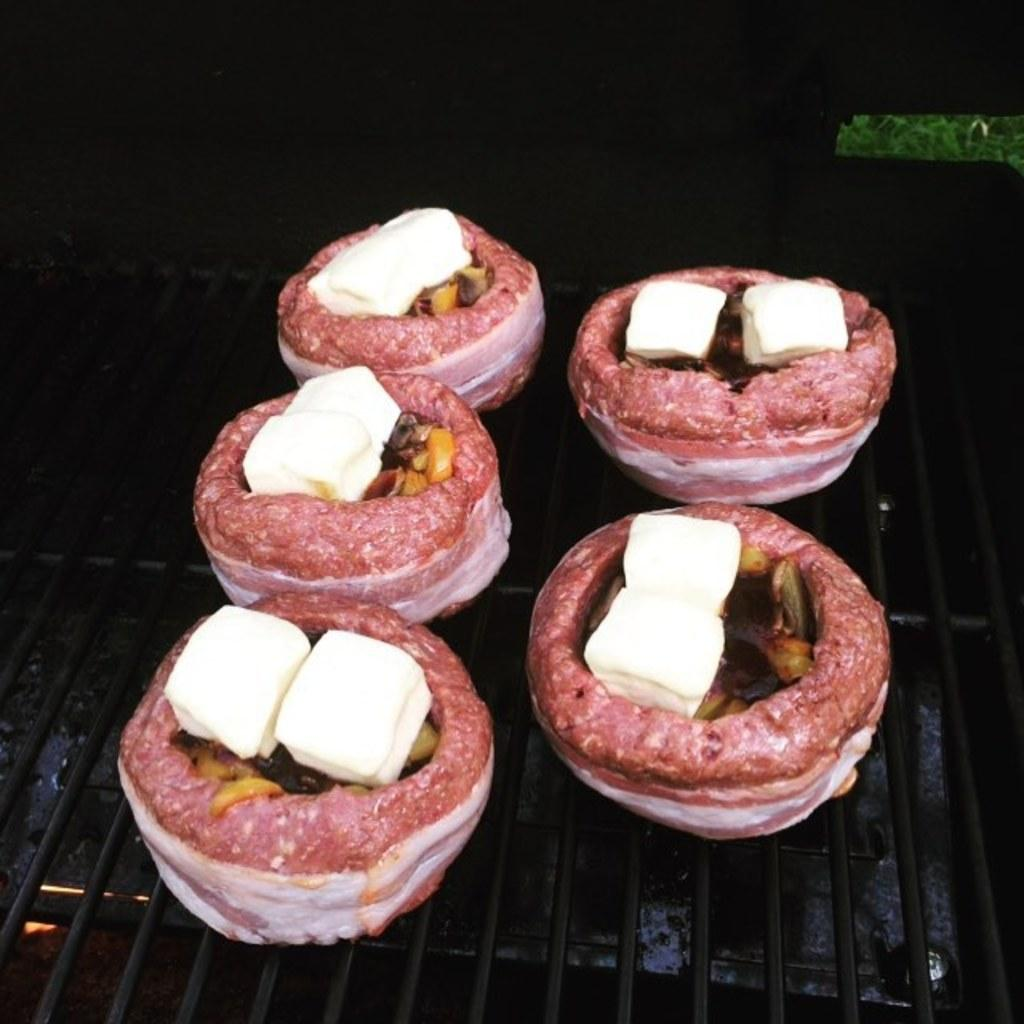What is being cooked or prepared in the image? There are food items on a barbecue grill in the image. Can you describe the background of the image? The background of the image is dark in color. How many letters are visible on the barbecue grill in the image? There are no letters visible on the barbecue grill in the image. What type of houses can be seen in the background of the image? There are no houses visible in the background of the image; it is described as dark in color. 